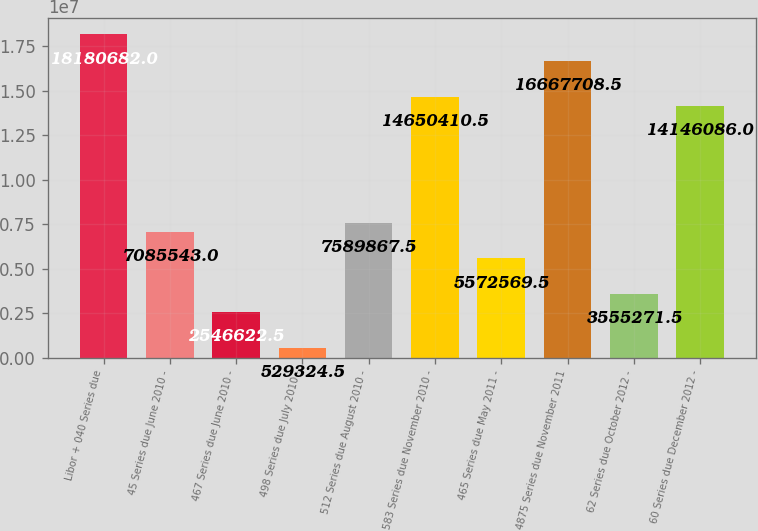Convert chart to OTSL. <chart><loc_0><loc_0><loc_500><loc_500><bar_chart><fcel>Libor + 040 Series due<fcel>45 Series due June 2010 -<fcel>467 Series due June 2010 -<fcel>498 Series due July 2010 -<fcel>512 Series due August 2010 -<fcel>583 Series due November 2010 -<fcel>465 Series due May 2011 -<fcel>4875 Series due November 2011<fcel>62 Series due October 2012 -<fcel>60 Series due December 2012 -<nl><fcel>1.81807e+07<fcel>7.08554e+06<fcel>2.54662e+06<fcel>529324<fcel>7.58987e+06<fcel>1.46504e+07<fcel>5.57257e+06<fcel>1.66677e+07<fcel>3.55527e+06<fcel>1.41461e+07<nl></chart> 